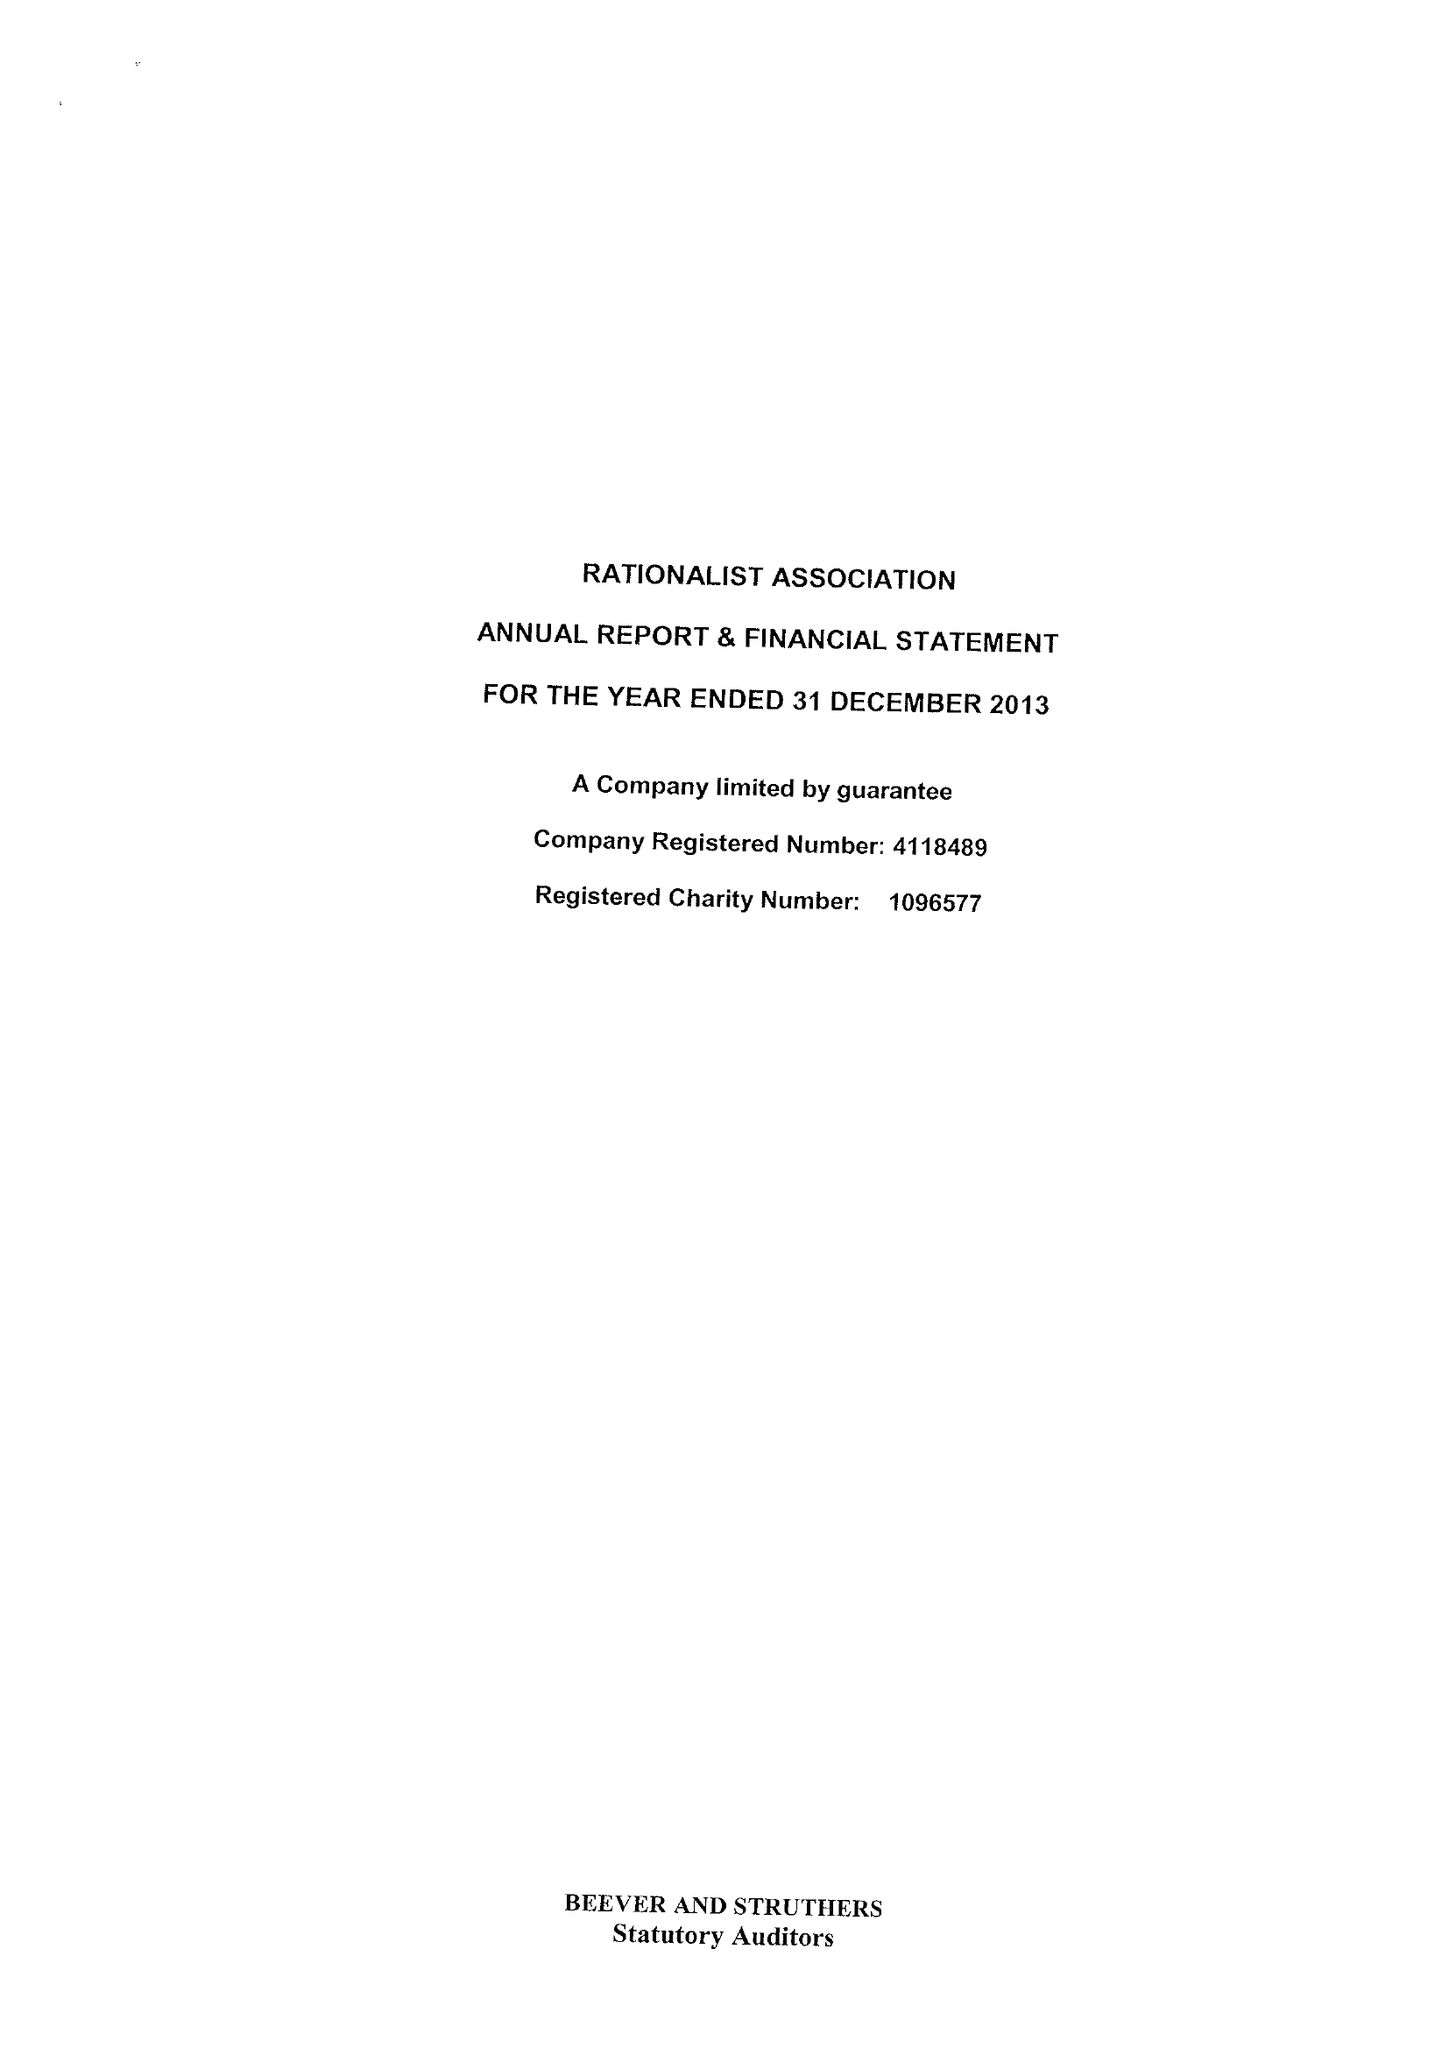What is the value for the income_annually_in_british_pounds?
Answer the question using a single word or phrase. 224296.00 